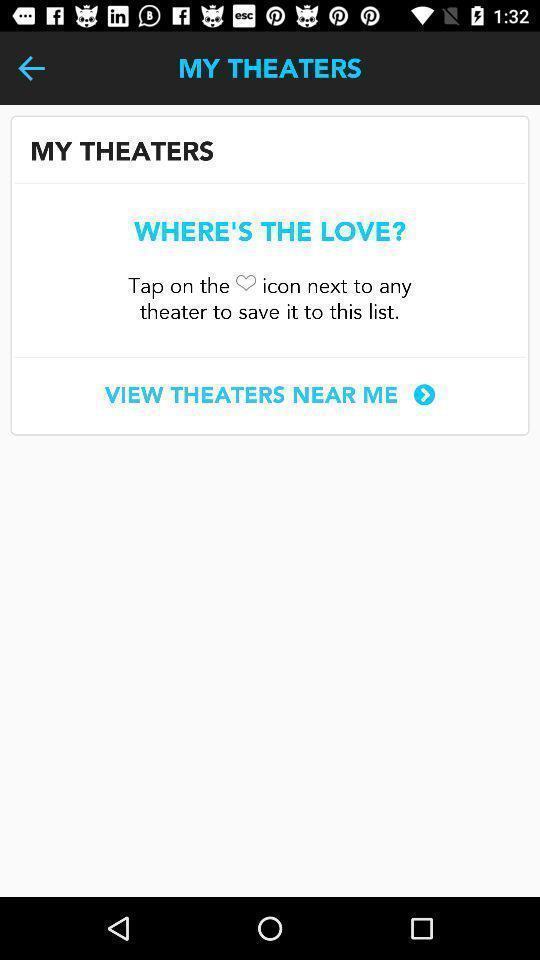What can you discern from this picture? Page displaying to view the theaters in a theater app. 